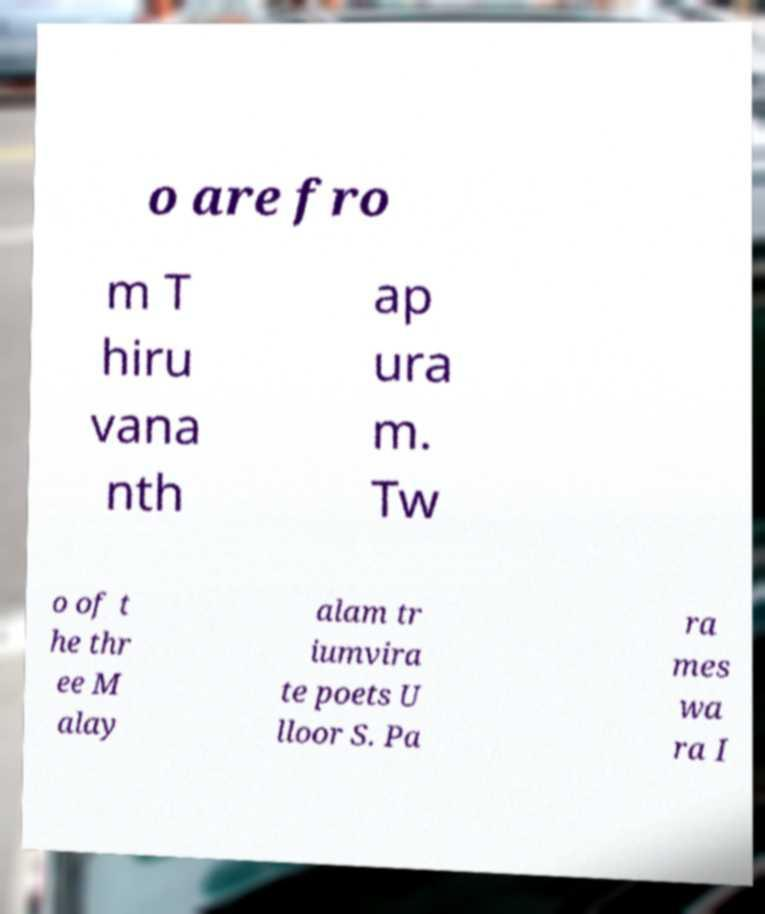Please read and relay the text visible in this image. What does it say? o are fro m T hiru vana nth ap ura m. Tw o of t he thr ee M alay alam tr iumvira te poets U lloor S. Pa ra mes wa ra I 